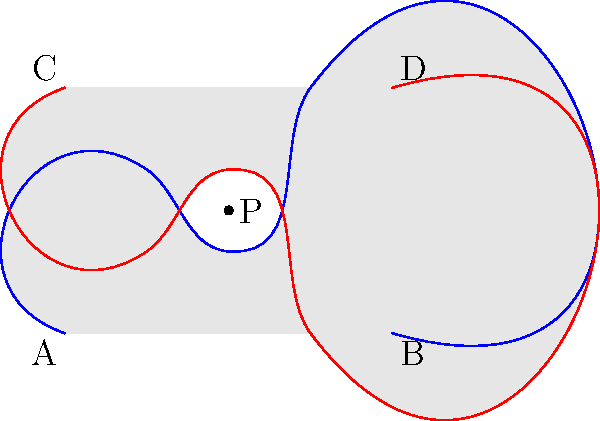Consider the negative space created by two dancers' movement paths, represented by the blue and red curves in the diagram. The shaded regions represent the space occupied by the dancers. Point P is located in the unoccupied space between the dancers. What is the genus of the topological space formed by this negative space, assuming the dance floor extends infinitely in all directions? To determine the genus of the topological space formed by the negative space, we need to follow these steps:

1. Identify the boundaries: The blue and red curves represent the boundaries of the space occupied by the dancers.

2. Consider the negative space: The unshaded region between and around the curves represents the negative space.

3. Extend the dance floor: Since the question states that the dance floor extends infinitely in all directions, we can consider this negative space as a subset of an infinite plane.

4. Count the number of holes: In topology, the genus of a surface is equal to the number of holes in the surface. In this case, we need to count the number of distinct regions of negative space that are completely enclosed by the dancers' movements.

5. Analyze the diagram: We can see that there are two distinct enclosed regions of negative space:
   a. The region between the two curves
   b. The region outside both curves (extending to infinity)

6. Determine the genus: Since there are two distinct regions, and one of them extends to infinity, the negative space forms a topological space with one hole.

Therefore, the genus of the topological space formed by this negative space is 1.
Answer: 1 